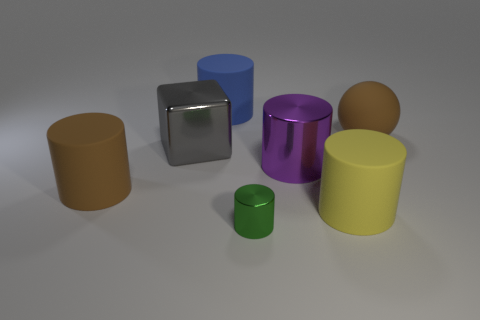What is the shape of the metallic object that is both behind the small green metallic cylinder and to the right of the big blue object?
Offer a very short reply. Cylinder. What number of gray blocks are in front of the brown rubber object left of the large yellow matte cylinder?
Offer a very short reply. 0. Are there any other things that have the same material as the small green cylinder?
Your response must be concise. Yes. How many things are either shiny things behind the big yellow matte cylinder or large purple objects?
Provide a short and direct response. 2. There is a brown thing that is on the left side of the ball; what size is it?
Your answer should be very brief. Large. What is the blue cylinder made of?
Offer a terse response. Rubber. There is a rubber thing behind the brown matte thing to the right of the big block; what shape is it?
Your response must be concise. Cylinder. How many other things are the same shape as the big gray shiny object?
Your answer should be very brief. 0. Are there any gray metal things in front of the yellow matte cylinder?
Offer a terse response. No. The ball has what color?
Ensure brevity in your answer.  Brown. 